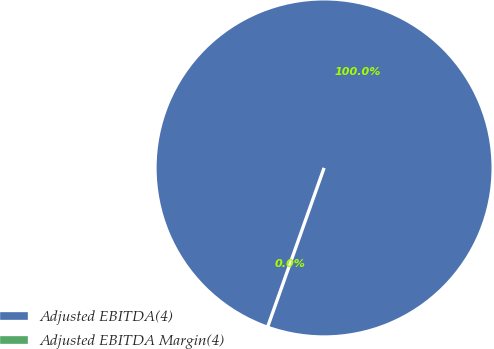Convert chart. <chart><loc_0><loc_0><loc_500><loc_500><pie_chart><fcel>Adjusted EBITDA(4)<fcel>Adjusted EBITDA Margin(4)<nl><fcel>100.0%<fcel>0.0%<nl></chart> 